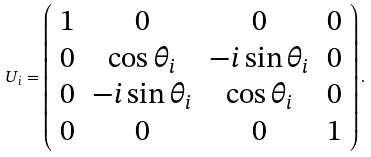<formula> <loc_0><loc_0><loc_500><loc_500>U _ { i } = \left ( { \begin{array} { c c c c } 1 & 0 & 0 & 0 \\ 0 & \cos \theta _ { i } & - i \sin \theta _ { i } & 0 \\ 0 & - i \sin \theta _ { i } & \cos \theta _ { i } & 0 \\ 0 & 0 & 0 & 1 \\ \end{array} } \right ) .</formula> 